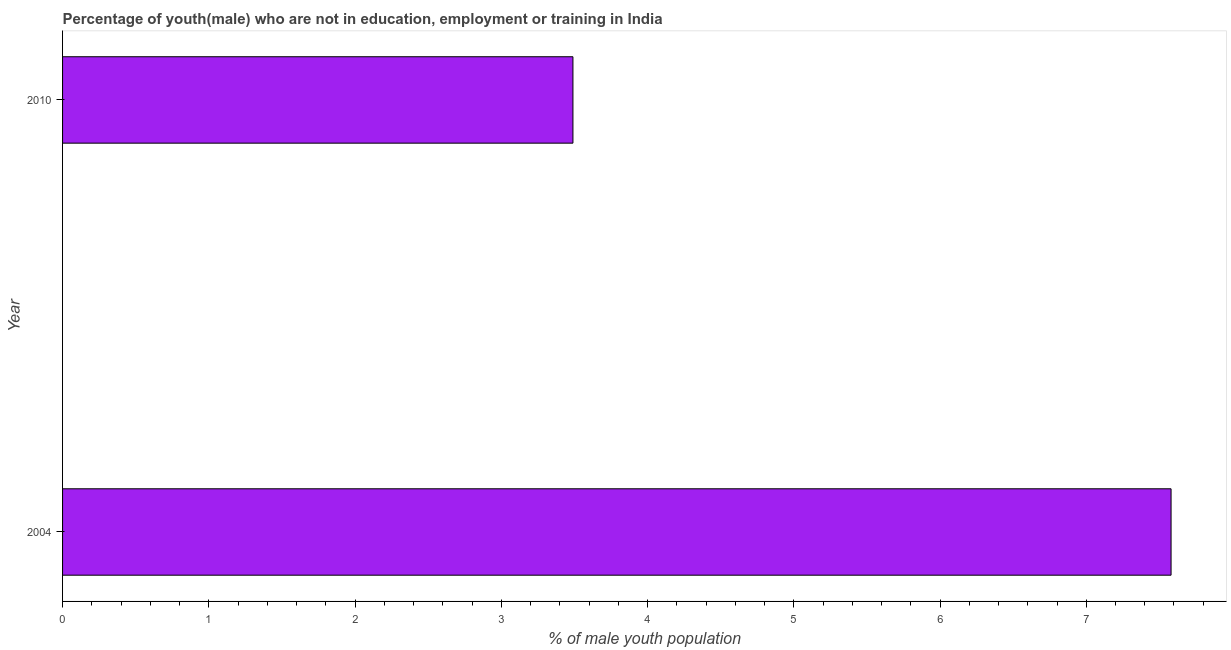Does the graph contain any zero values?
Offer a terse response. No. What is the title of the graph?
Offer a terse response. Percentage of youth(male) who are not in education, employment or training in India. What is the label or title of the X-axis?
Provide a short and direct response. % of male youth population. What is the label or title of the Y-axis?
Your answer should be very brief. Year. What is the unemployed male youth population in 2010?
Your answer should be very brief. 3.49. Across all years, what is the maximum unemployed male youth population?
Offer a very short reply. 7.58. Across all years, what is the minimum unemployed male youth population?
Your answer should be very brief. 3.49. In which year was the unemployed male youth population minimum?
Your answer should be compact. 2010. What is the sum of the unemployed male youth population?
Ensure brevity in your answer.  11.07. What is the difference between the unemployed male youth population in 2004 and 2010?
Offer a very short reply. 4.09. What is the average unemployed male youth population per year?
Give a very brief answer. 5.54. What is the median unemployed male youth population?
Make the answer very short. 5.53. Do a majority of the years between 2010 and 2004 (inclusive) have unemployed male youth population greater than 0.8 %?
Make the answer very short. No. What is the ratio of the unemployed male youth population in 2004 to that in 2010?
Ensure brevity in your answer.  2.17. Is the unemployed male youth population in 2004 less than that in 2010?
Your response must be concise. No. In how many years, is the unemployed male youth population greater than the average unemployed male youth population taken over all years?
Offer a terse response. 1. Are all the bars in the graph horizontal?
Give a very brief answer. Yes. What is the % of male youth population of 2004?
Make the answer very short. 7.58. What is the % of male youth population in 2010?
Keep it short and to the point. 3.49. What is the difference between the % of male youth population in 2004 and 2010?
Make the answer very short. 4.09. What is the ratio of the % of male youth population in 2004 to that in 2010?
Your answer should be very brief. 2.17. 